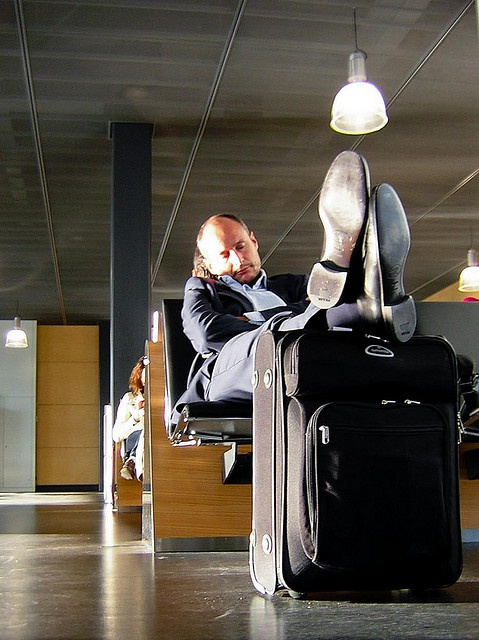Describe the objects in this image and their specific colors. I can see suitcase in black, darkgray, lightgray, and gray tones, people in black, lightgray, gray, and darkgray tones, bench in black, olive, gray, and maroon tones, chair in black, gray, and lightgray tones, and people in black, white, gray, and tan tones in this image. 